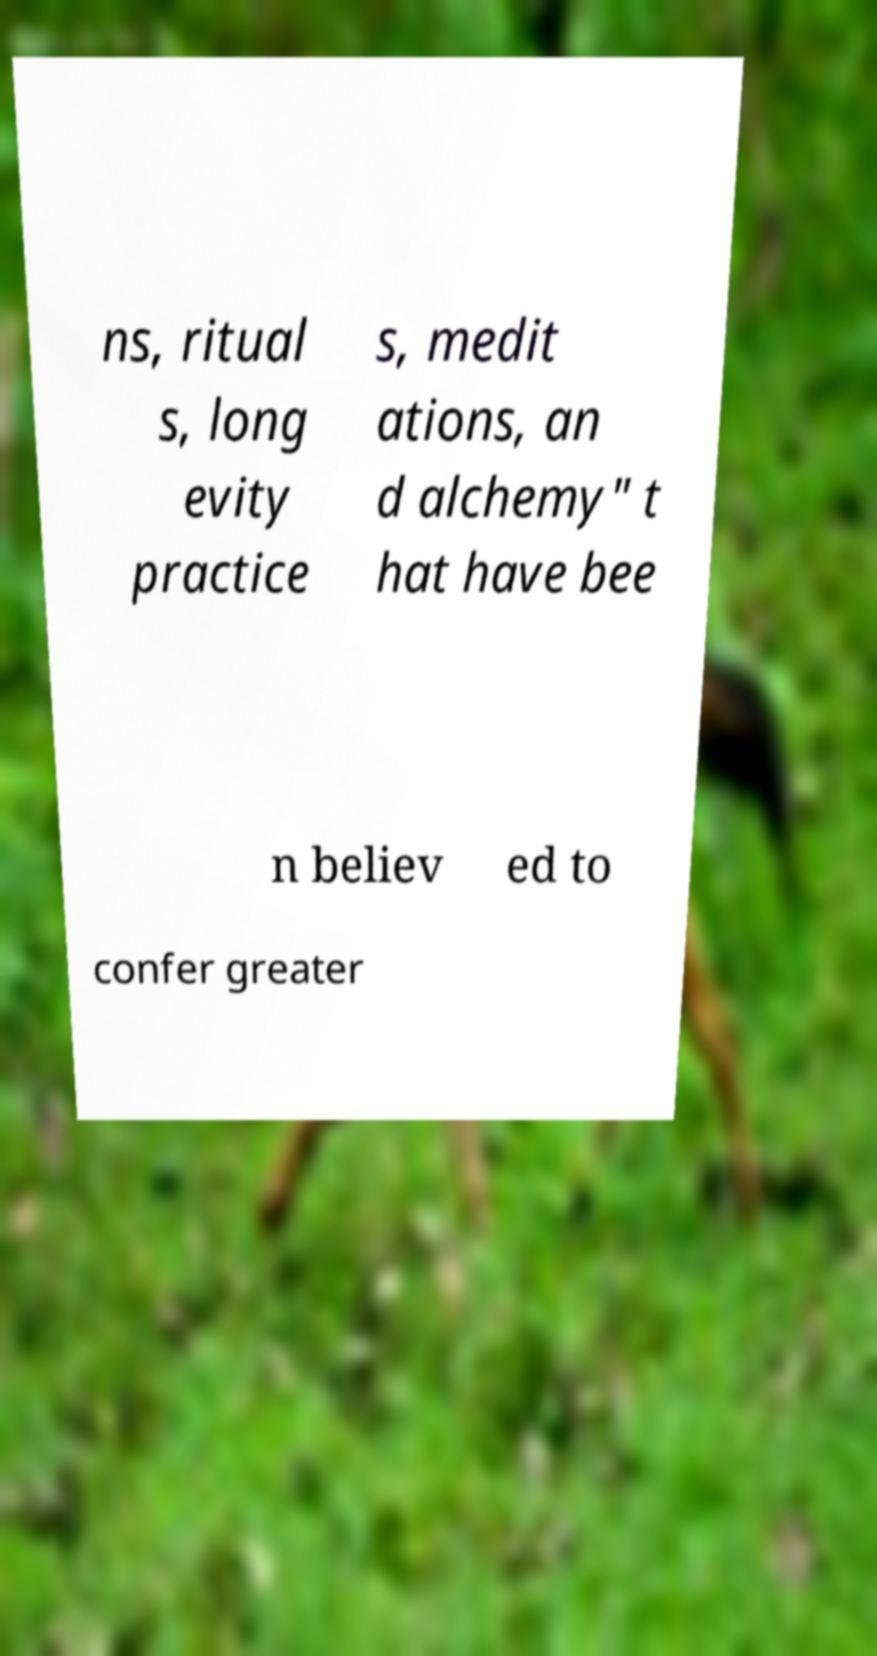Could you extract and type out the text from this image? ns, ritual s, long evity practice s, medit ations, an d alchemy" t hat have bee n believ ed to confer greater 